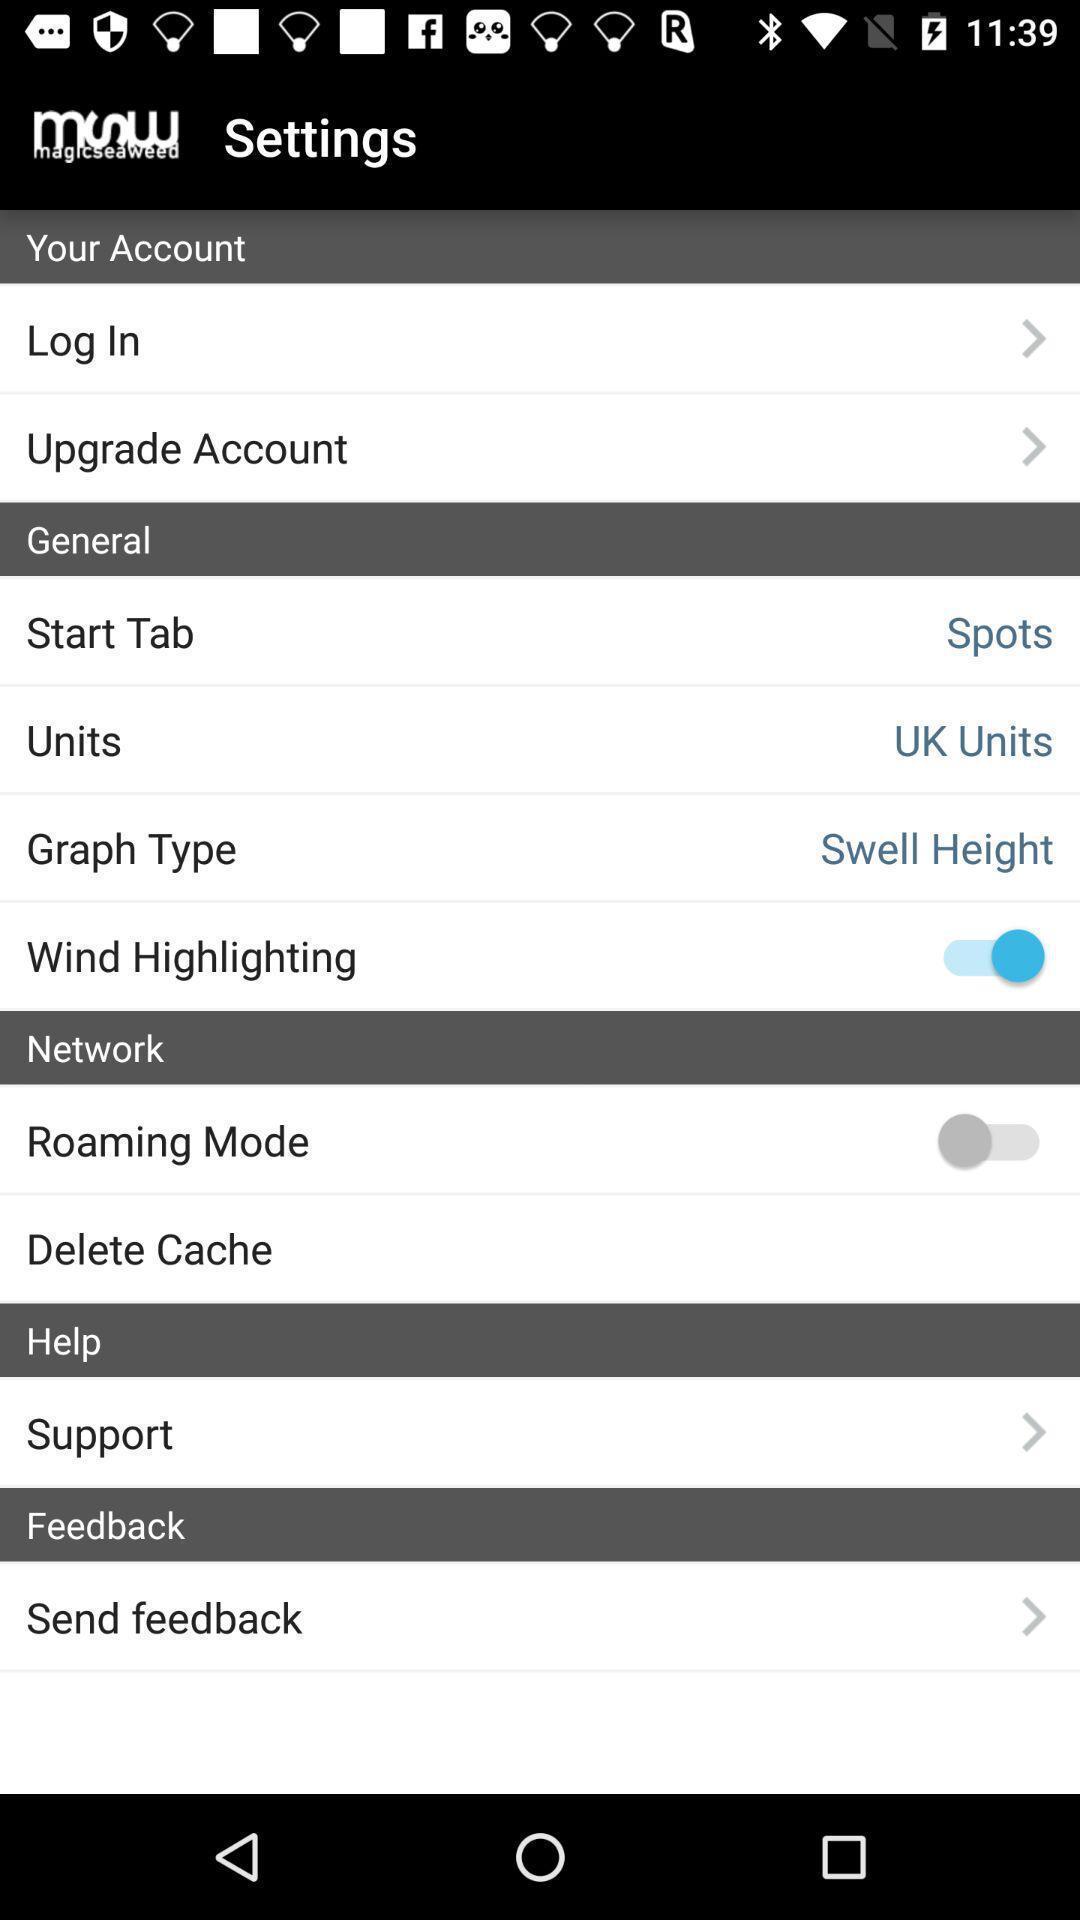Tell me what you see in this picture. Settings page of a weather news app. 